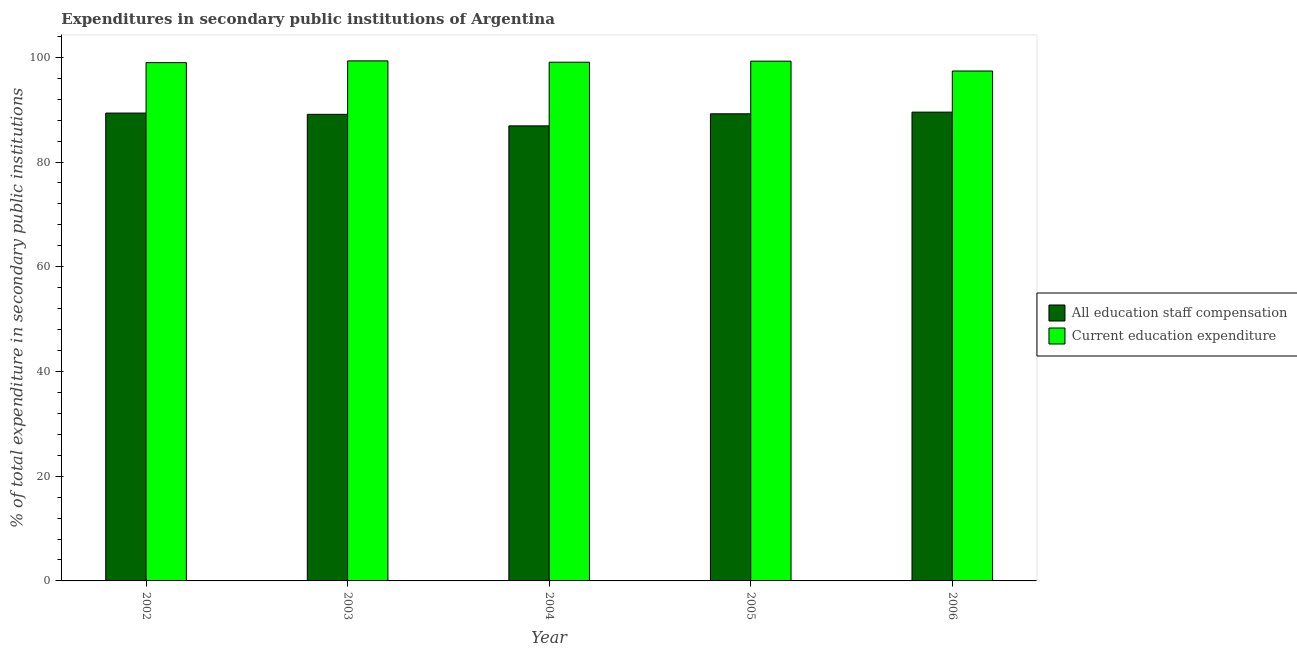How many groups of bars are there?
Your answer should be very brief. 5. Are the number of bars on each tick of the X-axis equal?
Make the answer very short. Yes. In how many cases, is the number of bars for a given year not equal to the number of legend labels?
Provide a short and direct response. 0. What is the expenditure in education in 2003?
Your answer should be very brief. 99.31. Across all years, what is the maximum expenditure in education?
Make the answer very short. 99.31. Across all years, what is the minimum expenditure in education?
Your response must be concise. 97.38. What is the total expenditure in education in the graph?
Give a very brief answer. 493.98. What is the difference between the expenditure in education in 2004 and that in 2006?
Keep it short and to the point. 1.68. What is the difference between the expenditure in staff compensation in 2005 and the expenditure in education in 2004?
Keep it short and to the point. 2.3. What is the average expenditure in staff compensation per year?
Provide a succinct answer. 88.82. What is the ratio of the expenditure in education in 2005 to that in 2006?
Your response must be concise. 1.02. Is the expenditure in staff compensation in 2002 less than that in 2005?
Provide a succinct answer. No. Is the difference between the expenditure in staff compensation in 2005 and 2006 greater than the difference between the expenditure in education in 2005 and 2006?
Give a very brief answer. No. What is the difference between the highest and the second highest expenditure in staff compensation?
Provide a short and direct response. 0.18. What is the difference between the highest and the lowest expenditure in education?
Your response must be concise. 1.93. What does the 1st bar from the left in 2004 represents?
Keep it short and to the point. All education staff compensation. What does the 1st bar from the right in 2003 represents?
Your answer should be very brief. Current education expenditure. Are all the bars in the graph horizontal?
Provide a succinct answer. No. What is the difference between two consecutive major ticks on the Y-axis?
Offer a very short reply. 20. Does the graph contain any zero values?
Offer a terse response. No. Does the graph contain grids?
Offer a very short reply. No. How many legend labels are there?
Give a very brief answer. 2. How are the legend labels stacked?
Your answer should be very brief. Vertical. What is the title of the graph?
Your response must be concise. Expenditures in secondary public institutions of Argentina. Does "Fraud firms" appear as one of the legend labels in the graph?
Give a very brief answer. No. What is the label or title of the Y-axis?
Provide a short and direct response. % of total expenditure in secondary public institutions. What is the % of total expenditure in secondary public institutions in All education staff compensation in 2002?
Provide a short and direct response. 89.35. What is the % of total expenditure in secondary public institutions in Current education expenditure in 2002?
Offer a terse response. 98.98. What is the % of total expenditure in secondary public institutions in All education staff compensation in 2003?
Your answer should be compact. 89.1. What is the % of total expenditure in secondary public institutions of Current education expenditure in 2003?
Give a very brief answer. 99.31. What is the % of total expenditure in secondary public institutions in All education staff compensation in 2004?
Make the answer very short. 86.9. What is the % of total expenditure in secondary public institutions of Current education expenditure in 2004?
Your answer should be very brief. 99.06. What is the % of total expenditure in secondary public institutions in All education staff compensation in 2005?
Keep it short and to the point. 89.2. What is the % of total expenditure in secondary public institutions of Current education expenditure in 2005?
Your response must be concise. 99.26. What is the % of total expenditure in secondary public institutions in All education staff compensation in 2006?
Keep it short and to the point. 89.52. What is the % of total expenditure in secondary public institutions of Current education expenditure in 2006?
Give a very brief answer. 97.38. Across all years, what is the maximum % of total expenditure in secondary public institutions in All education staff compensation?
Provide a succinct answer. 89.52. Across all years, what is the maximum % of total expenditure in secondary public institutions of Current education expenditure?
Give a very brief answer. 99.31. Across all years, what is the minimum % of total expenditure in secondary public institutions in All education staff compensation?
Your response must be concise. 86.9. Across all years, what is the minimum % of total expenditure in secondary public institutions in Current education expenditure?
Offer a very short reply. 97.38. What is the total % of total expenditure in secondary public institutions in All education staff compensation in the graph?
Make the answer very short. 444.07. What is the total % of total expenditure in secondary public institutions of Current education expenditure in the graph?
Keep it short and to the point. 493.98. What is the difference between the % of total expenditure in secondary public institutions of All education staff compensation in 2002 and that in 2003?
Keep it short and to the point. 0.24. What is the difference between the % of total expenditure in secondary public institutions in Current education expenditure in 2002 and that in 2003?
Offer a terse response. -0.33. What is the difference between the % of total expenditure in secondary public institutions in All education staff compensation in 2002 and that in 2004?
Provide a succinct answer. 2.45. What is the difference between the % of total expenditure in secondary public institutions of Current education expenditure in 2002 and that in 2004?
Make the answer very short. -0.08. What is the difference between the % of total expenditure in secondary public institutions of All education staff compensation in 2002 and that in 2005?
Keep it short and to the point. 0.14. What is the difference between the % of total expenditure in secondary public institutions in Current education expenditure in 2002 and that in 2005?
Keep it short and to the point. -0.28. What is the difference between the % of total expenditure in secondary public institutions of All education staff compensation in 2002 and that in 2006?
Your answer should be compact. -0.18. What is the difference between the % of total expenditure in secondary public institutions of Current education expenditure in 2002 and that in 2006?
Offer a terse response. 1.6. What is the difference between the % of total expenditure in secondary public institutions in All education staff compensation in 2003 and that in 2004?
Your answer should be very brief. 2.2. What is the difference between the % of total expenditure in secondary public institutions of Current education expenditure in 2003 and that in 2004?
Your answer should be compact. 0.26. What is the difference between the % of total expenditure in secondary public institutions of All education staff compensation in 2003 and that in 2005?
Your answer should be very brief. -0.1. What is the difference between the % of total expenditure in secondary public institutions in Current education expenditure in 2003 and that in 2005?
Provide a succinct answer. 0.05. What is the difference between the % of total expenditure in secondary public institutions of All education staff compensation in 2003 and that in 2006?
Your response must be concise. -0.42. What is the difference between the % of total expenditure in secondary public institutions of Current education expenditure in 2003 and that in 2006?
Your answer should be compact. 1.93. What is the difference between the % of total expenditure in secondary public institutions of All education staff compensation in 2004 and that in 2005?
Your answer should be compact. -2.3. What is the difference between the % of total expenditure in secondary public institutions of Current education expenditure in 2004 and that in 2005?
Offer a very short reply. -0.2. What is the difference between the % of total expenditure in secondary public institutions of All education staff compensation in 2004 and that in 2006?
Your answer should be compact. -2.62. What is the difference between the % of total expenditure in secondary public institutions of Current education expenditure in 2004 and that in 2006?
Offer a terse response. 1.68. What is the difference between the % of total expenditure in secondary public institutions in All education staff compensation in 2005 and that in 2006?
Provide a succinct answer. -0.32. What is the difference between the % of total expenditure in secondary public institutions in Current education expenditure in 2005 and that in 2006?
Provide a short and direct response. 1.88. What is the difference between the % of total expenditure in secondary public institutions in All education staff compensation in 2002 and the % of total expenditure in secondary public institutions in Current education expenditure in 2003?
Offer a terse response. -9.97. What is the difference between the % of total expenditure in secondary public institutions in All education staff compensation in 2002 and the % of total expenditure in secondary public institutions in Current education expenditure in 2004?
Make the answer very short. -9.71. What is the difference between the % of total expenditure in secondary public institutions of All education staff compensation in 2002 and the % of total expenditure in secondary public institutions of Current education expenditure in 2005?
Your answer should be compact. -9.91. What is the difference between the % of total expenditure in secondary public institutions in All education staff compensation in 2002 and the % of total expenditure in secondary public institutions in Current education expenditure in 2006?
Your response must be concise. -8.03. What is the difference between the % of total expenditure in secondary public institutions in All education staff compensation in 2003 and the % of total expenditure in secondary public institutions in Current education expenditure in 2004?
Your response must be concise. -9.95. What is the difference between the % of total expenditure in secondary public institutions in All education staff compensation in 2003 and the % of total expenditure in secondary public institutions in Current education expenditure in 2005?
Offer a very short reply. -10.15. What is the difference between the % of total expenditure in secondary public institutions in All education staff compensation in 2003 and the % of total expenditure in secondary public institutions in Current education expenditure in 2006?
Provide a succinct answer. -8.27. What is the difference between the % of total expenditure in secondary public institutions of All education staff compensation in 2004 and the % of total expenditure in secondary public institutions of Current education expenditure in 2005?
Your answer should be compact. -12.36. What is the difference between the % of total expenditure in secondary public institutions of All education staff compensation in 2004 and the % of total expenditure in secondary public institutions of Current education expenditure in 2006?
Offer a very short reply. -10.48. What is the difference between the % of total expenditure in secondary public institutions of All education staff compensation in 2005 and the % of total expenditure in secondary public institutions of Current education expenditure in 2006?
Keep it short and to the point. -8.17. What is the average % of total expenditure in secondary public institutions in All education staff compensation per year?
Keep it short and to the point. 88.81. What is the average % of total expenditure in secondary public institutions of Current education expenditure per year?
Provide a succinct answer. 98.8. In the year 2002, what is the difference between the % of total expenditure in secondary public institutions of All education staff compensation and % of total expenditure in secondary public institutions of Current education expenditure?
Your response must be concise. -9.63. In the year 2003, what is the difference between the % of total expenditure in secondary public institutions of All education staff compensation and % of total expenditure in secondary public institutions of Current education expenditure?
Offer a terse response. -10.21. In the year 2004, what is the difference between the % of total expenditure in secondary public institutions in All education staff compensation and % of total expenditure in secondary public institutions in Current education expenditure?
Provide a short and direct response. -12.16. In the year 2005, what is the difference between the % of total expenditure in secondary public institutions of All education staff compensation and % of total expenditure in secondary public institutions of Current education expenditure?
Offer a terse response. -10.05. In the year 2006, what is the difference between the % of total expenditure in secondary public institutions of All education staff compensation and % of total expenditure in secondary public institutions of Current education expenditure?
Provide a succinct answer. -7.86. What is the ratio of the % of total expenditure in secondary public institutions in All education staff compensation in 2002 to that in 2003?
Offer a very short reply. 1. What is the ratio of the % of total expenditure in secondary public institutions in All education staff compensation in 2002 to that in 2004?
Your response must be concise. 1.03. What is the ratio of the % of total expenditure in secondary public institutions in Current education expenditure in 2002 to that in 2005?
Provide a short and direct response. 1. What is the ratio of the % of total expenditure in secondary public institutions in All education staff compensation in 2002 to that in 2006?
Ensure brevity in your answer.  1. What is the ratio of the % of total expenditure in secondary public institutions of Current education expenditure in 2002 to that in 2006?
Keep it short and to the point. 1.02. What is the ratio of the % of total expenditure in secondary public institutions in All education staff compensation in 2003 to that in 2004?
Your response must be concise. 1.03. What is the ratio of the % of total expenditure in secondary public institutions in Current education expenditure in 2003 to that in 2004?
Offer a very short reply. 1. What is the ratio of the % of total expenditure in secondary public institutions in All education staff compensation in 2003 to that in 2005?
Your response must be concise. 1. What is the ratio of the % of total expenditure in secondary public institutions of Current education expenditure in 2003 to that in 2006?
Your answer should be compact. 1.02. What is the ratio of the % of total expenditure in secondary public institutions of All education staff compensation in 2004 to that in 2005?
Provide a succinct answer. 0.97. What is the ratio of the % of total expenditure in secondary public institutions of All education staff compensation in 2004 to that in 2006?
Provide a succinct answer. 0.97. What is the ratio of the % of total expenditure in secondary public institutions of Current education expenditure in 2004 to that in 2006?
Give a very brief answer. 1.02. What is the ratio of the % of total expenditure in secondary public institutions in All education staff compensation in 2005 to that in 2006?
Ensure brevity in your answer.  1. What is the ratio of the % of total expenditure in secondary public institutions in Current education expenditure in 2005 to that in 2006?
Keep it short and to the point. 1.02. What is the difference between the highest and the second highest % of total expenditure in secondary public institutions of All education staff compensation?
Provide a succinct answer. 0.18. What is the difference between the highest and the second highest % of total expenditure in secondary public institutions of Current education expenditure?
Offer a very short reply. 0.05. What is the difference between the highest and the lowest % of total expenditure in secondary public institutions of All education staff compensation?
Keep it short and to the point. 2.62. What is the difference between the highest and the lowest % of total expenditure in secondary public institutions in Current education expenditure?
Provide a succinct answer. 1.93. 